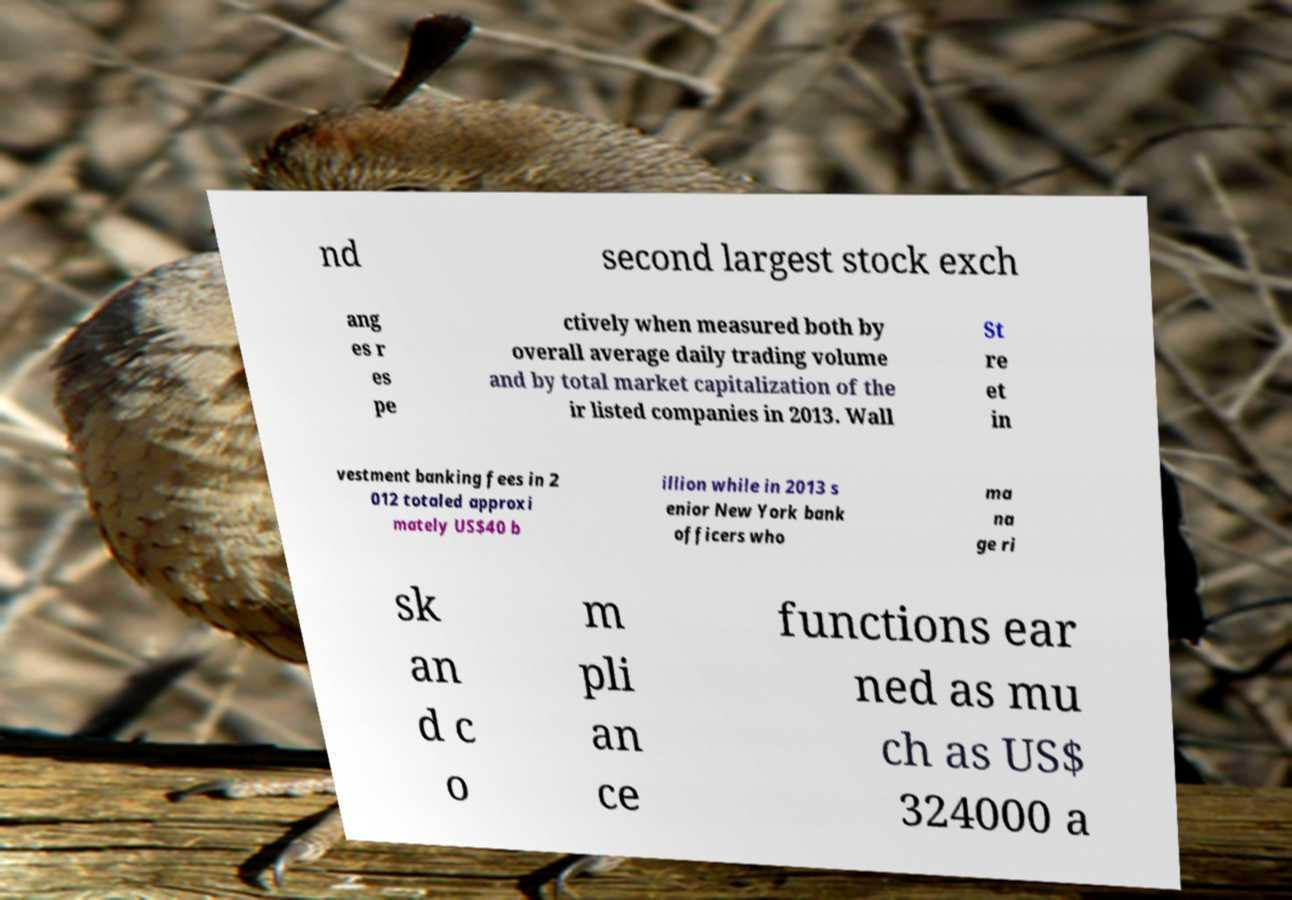Can you read and provide the text displayed in the image?This photo seems to have some interesting text. Can you extract and type it out for me? nd second largest stock exch ang es r es pe ctively when measured both by overall average daily trading volume and by total market capitalization of the ir listed companies in 2013. Wall St re et in vestment banking fees in 2 012 totaled approxi mately US$40 b illion while in 2013 s enior New York bank officers who ma na ge ri sk an d c o m pli an ce functions ear ned as mu ch as US$ 324000 a 